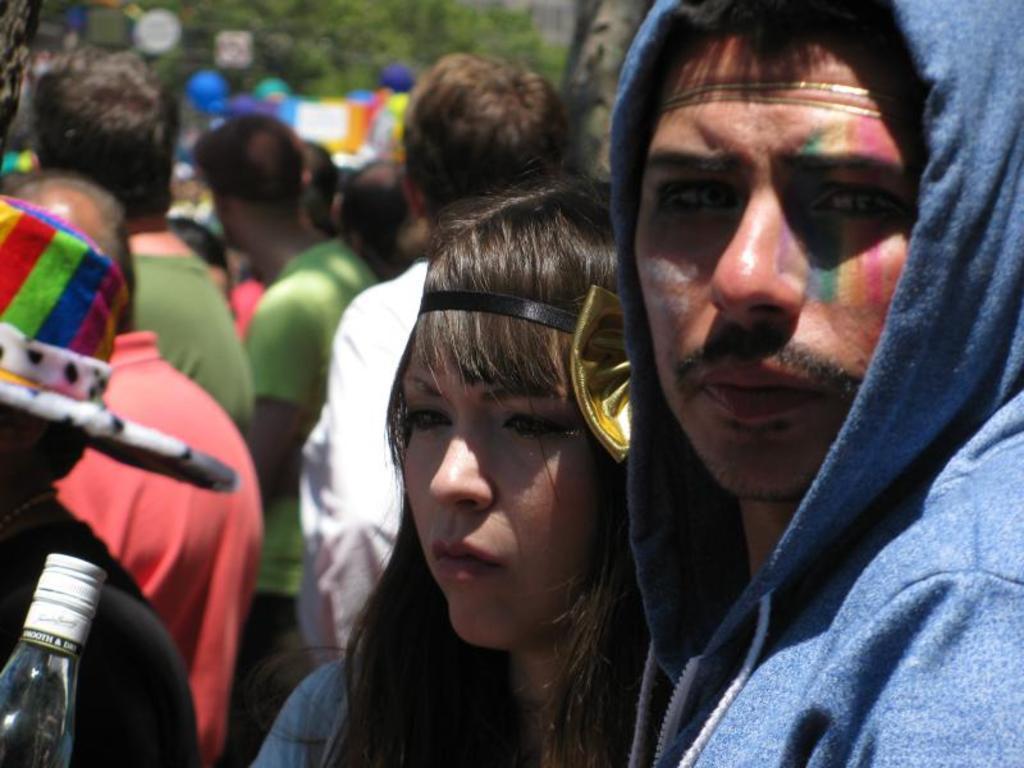How would you summarize this image in a sentence or two? In this image we can see persons. On the left side of the image it looks like a bottle and a person. In the background of the image there are some persons, trees and some other objects. 